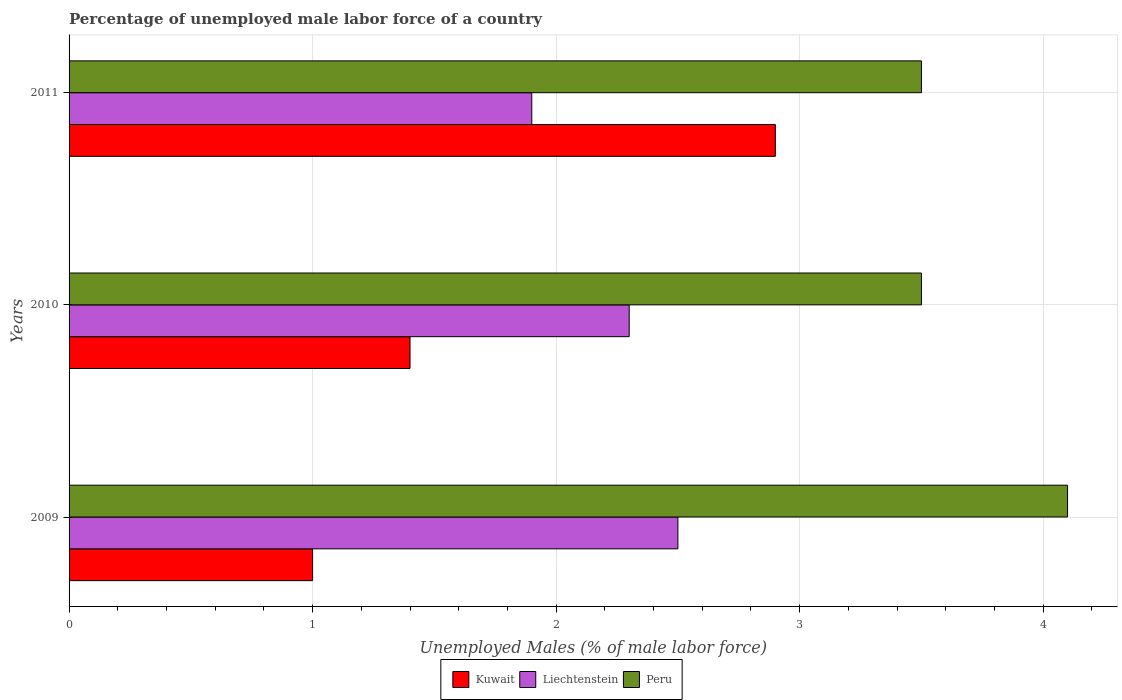How many groups of bars are there?
Your answer should be compact. 3. Are the number of bars on each tick of the Y-axis equal?
Ensure brevity in your answer.  Yes. How many bars are there on the 1st tick from the bottom?
Give a very brief answer. 3. What is the label of the 1st group of bars from the top?
Your answer should be compact. 2011. In how many cases, is the number of bars for a given year not equal to the number of legend labels?
Your answer should be very brief. 0. What is the percentage of unemployed male labor force in Kuwait in 2010?
Offer a very short reply. 1.4. Across all years, what is the minimum percentage of unemployed male labor force in Liechtenstein?
Ensure brevity in your answer.  1.9. In which year was the percentage of unemployed male labor force in Peru maximum?
Provide a short and direct response. 2009. What is the total percentage of unemployed male labor force in Liechtenstein in the graph?
Offer a terse response. 6.7. What is the difference between the percentage of unemployed male labor force in Kuwait in 2009 and that in 2011?
Ensure brevity in your answer.  -1.9. What is the difference between the percentage of unemployed male labor force in Kuwait in 2010 and the percentage of unemployed male labor force in Peru in 2011?
Ensure brevity in your answer.  -2.1. What is the average percentage of unemployed male labor force in Liechtenstein per year?
Provide a succinct answer. 2.23. In the year 2011, what is the difference between the percentage of unemployed male labor force in Kuwait and percentage of unemployed male labor force in Liechtenstein?
Provide a succinct answer. 1. In how many years, is the percentage of unemployed male labor force in Kuwait greater than 1.4 %?
Your response must be concise. 1. What is the ratio of the percentage of unemployed male labor force in Liechtenstein in 2009 to that in 2011?
Make the answer very short. 1.32. Is the difference between the percentage of unemployed male labor force in Kuwait in 2009 and 2011 greater than the difference between the percentage of unemployed male labor force in Liechtenstein in 2009 and 2011?
Give a very brief answer. No. What is the difference between the highest and the second highest percentage of unemployed male labor force in Peru?
Provide a succinct answer. 0.6. What is the difference between the highest and the lowest percentage of unemployed male labor force in Kuwait?
Your response must be concise. 1.9. What does the 3rd bar from the top in 2010 represents?
Make the answer very short. Kuwait. What does the 2nd bar from the bottom in 2010 represents?
Provide a short and direct response. Liechtenstein. Are all the bars in the graph horizontal?
Your answer should be very brief. Yes. What is the difference between two consecutive major ticks on the X-axis?
Provide a short and direct response. 1. Are the values on the major ticks of X-axis written in scientific E-notation?
Give a very brief answer. No. Does the graph contain grids?
Give a very brief answer. Yes. How many legend labels are there?
Give a very brief answer. 3. How are the legend labels stacked?
Offer a terse response. Horizontal. What is the title of the graph?
Offer a terse response. Percentage of unemployed male labor force of a country. What is the label or title of the X-axis?
Make the answer very short. Unemployed Males (% of male labor force). What is the Unemployed Males (% of male labor force) in Kuwait in 2009?
Offer a very short reply. 1. What is the Unemployed Males (% of male labor force) of Liechtenstein in 2009?
Keep it short and to the point. 2.5. What is the Unemployed Males (% of male labor force) in Peru in 2009?
Offer a terse response. 4.1. What is the Unemployed Males (% of male labor force) of Kuwait in 2010?
Give a very brief answer. 1.4. What is the Unemployed Males (% of male labor force) in Liechtenstein in 2010?
Your response must be concise. 2.3. What is the Unemployed Males (% of male labor force) of Peru in 2010?
Provide a short and direct response. 3.5. What is the Unemployed Males (% of male labor force) of Kuwait in 2011?
Provide a succinct answer. 2.9. What is the Unemployed Males (% of male labor force) of Liechtenstein in 2011?
Provide a short and direct response. 1.9. Across all years, what is the maximum Unemployed Males (% of male labor force) in Kuwait?
Give a very brief answer. 2.9. Across all years, what is the maximum Unemployed Males (% of male labor force) in Peru?
Keep it short and to the point. 4.1. Across all years, what is the minimum Unemployed Males (% of male labor force) of Kuwait?
Ensure brevity in your answer.  1. Across all years, what is the minimum Unemployed Males (% of male labor force) in Liechtenstein?
Offer a very short reply. 1.9. What is the total Unemployed Males (% of male labor force) of Liechtenstein in the graph?
Keep it short and to the point. 6.7. What is the total Unemployed Males (% of male labor force) in Peru in the graph?
Your answer should be very brief. 11.1. What is the difference between the Unemployed Males (% of male labor force) of Kuwait in 2009 and that in 2011?
Your response must be concise. -1.9. What is the difference between the Unemployed Males (% of male labor force) of Liechtenstein in 2009 and that in 2011?
Give a very brief answer. 0.6. What is the difference between the Unemployed Males (% of male labor force) in Peru in 2009 and that in 2011?
Your response must be concise. 0.6. What is the difference between the Unemployed Males (% of male labor force) of Kuwait in 2010 and that in 2011?
Your answer should be very brief. -1.5. What is the difference between the Unemployed Males (% of male labor force) of Liechtenstein in 2009 and the Unemployed Males (% of male labor force) of Peru in 2010?
Provide a short and direct response. -1. What is the difference between the Unemployed Males (% of male labor force) of Kuwait in 2009 and the Unemployed Males (% of male labor force) of Liechtenstein in 2011?
Your answer should be compact. -0.9. What is the difference between the Unemployed Males (% of male labor force) in Liechtenstein in 2009 and the Unemployed Males (% of male labor force) in Peru in 2011?
Provide a short and direct response. -1. What is the difference between the Unemployed Males (% of male labor force) of Liechtenstein in 2010 and the Unemployed Males (% of male labor force) of Peru in 2011?
Give a very brief answer. -1.2. What is the average Unemployed Males (% of male labor force) of Kuwait per year?
Offer a terse response. 1.77. What is the average Unemployed Males (% of male labor force) in Liechtenstein per year?
Ensure brevity in your answer.  2.23. In the year 2009, what is the difference between the Unemployed Males (% of male labor force) in Kuwait and Unemployed Males (% of male labor force) in Liechtenstein?
Ensure brevity in your answer.  -1.5. In the year 2009, what is the difference between the Unemployed Males (% of male labor force) of Kuwait and Unemployed Males (% of male labor force) of Peru?
Keep it short and to the point. -3.1. In the year 2009, what is the difference between the Unemployed Males (% of male labor force) of Liechtenstein and Unemployed Males (% of male labor force) of Peru?
Your response must be concise. -1.6. In the year 2011, what is the difference between the Unemployed Males (% of male labor force) of Kuwait and Unemployed Males (% of male labor force) of Liechtenstein?
Your answer should be very brief. 1. In the year 2011, what is the difference between the Unemployed Males (% of male labor force) in Liechtenstein and Unemployed Males (% of male labor force) in Peru?
Provide a short and direct response. -1.6. What is the ratio of the Unemployed Males (% of male labor force) of Liechtenstein in 2009 to that in 2010?
Provide a short and direct response. 1.09. What is the ratio of the Unemployed Males (% of male labor force) in Peru in 2009 to that in 2010?
Offer a very short reply. 1.17. What is the ratio of the Unemployed Males (% of male labor force) of Kuwait in 2009 to that in 2011?
Ensure brevity in your answer.  0.34. What is the ratio of the Unemployed Males (% of male labor force) in Liechtenstein in 2009 to that in 2011?
Your response must be concise. 1.32. What is the ratio of the Unemployed Males (% of male labor force) of Peru in 2009 to that in 2011?
Make the answer very short. 1.17. What is the ratio of the Unemployed Males (% of male labor force) in Kuwait in 2010 to that in 2011?
Provide a short and direct response. 0.48. What is the ratio of the Unemployed Males (% of male labor force) of Liechtenstein in 2010 to that in 2011?
Give a very brief answer. 1.21. What is the ratio of the Unemployed Males (% of male labor force) of Peru in 2010 to that in 2011?
Ensure brevity in your answer.  1. What is the difference between the highest and the second highest Unemployed Males (% of male labor force) in Kuwait?
Your answer should be very brief. 1.5. What is the difference between the highest and the lowest Unemployed Males (% of male labor force) in Peru?
Offer a very short reply. 0.6. 